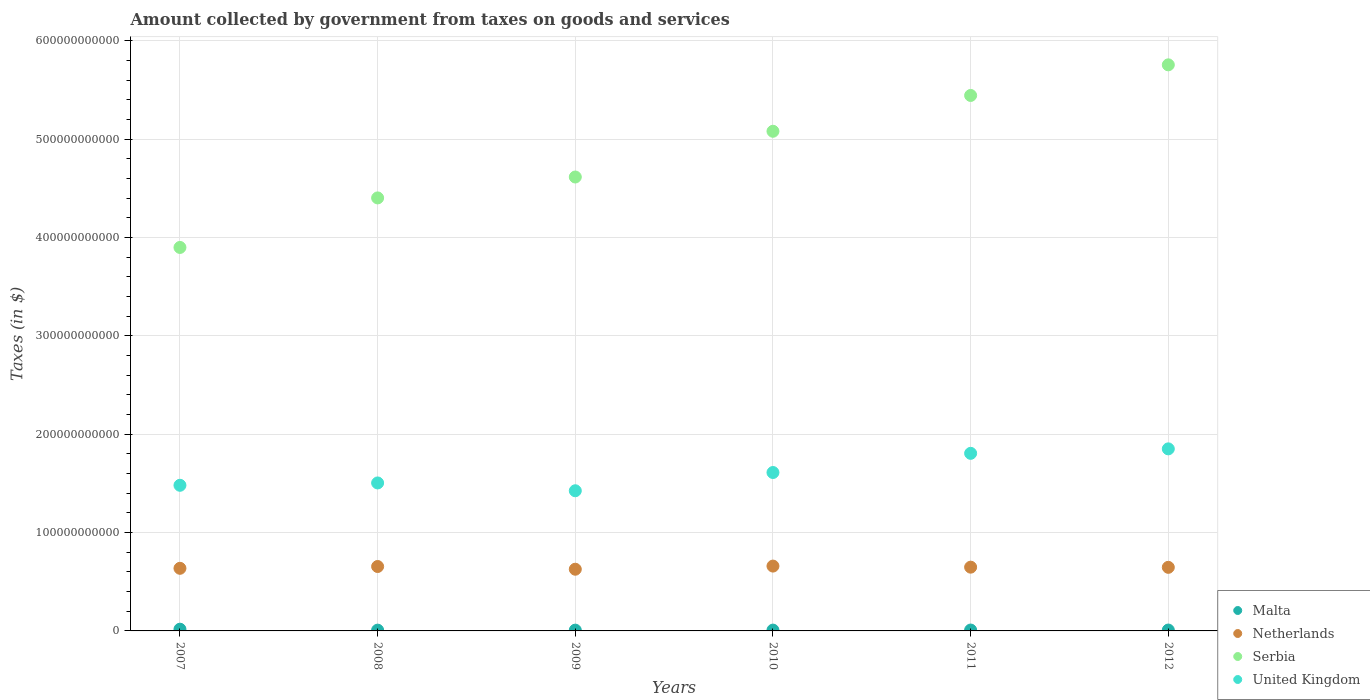How many different coloured dotlines are there?
Ensure brevity in your answer.  4. Is the number of dotlines equal to the number of legend labels?
Provide a succinct answer. Yes. What is the amount collected by government from taxes on goods and services in Serbia in 2008?
Ensure brevity in your answer.  4.40e+11. Across all years, what is the maximum amount collected by government from taxes on goods and services in Netherlands?
Your response must be concise. 6.59e+1. Across all years, what is the minimum amount collected by government from taxes on goods and services in United Kingdom?
Give a very brief answer. 1.43e+11. What is the total amount collected by government from taxes on goods and services in Malta in the graph?
Keep it short and to the point. 5.97e+09. What is the difference between the amount collected by government from taxes on goods and services in Malta in 2008 and that in 2011?
Give a very brief answer. -9.64e+07. What is the difference between the amount collected by government from taxes on goods and services in Netherlands in 2009 and the amount collected by government from taxes on goods and services in Malta in 2008?
Your response must be concise. 6.19e+1. What is the average amount collected by government from taxes on goods and services in Malta per year?
Ensure brevity in your answer.  9.95e+08. In the year 2011, what is the difference between the amount collected by government from taxes on goods and services in Serbia and amount collected by government from taxes on goods and services in Netherlands?
Provide a succinct answer. 4.80e+11. What is the ratio of the amount collected by government from taxes on goods and services in Malta in 2009 to that in 2010?
Provide a short and direct response. 0.97. What is the difference between the highest and the second highest amount collected by government from taxes on goods and services in Serbia?
Give a very brief answer. 3.11e+1. What is the difference between the highest and the lowest amount collected by government from taxes on goods and services in United Kingdom?
Provide a short and direct response. 4.26e+1. In how many years, is the amount collected by government from taxes on goods and services in United Kingdom greater than the average amount collected by government from taxes on goods and services in United Kingdom taken over all years?
Make the answer very short. 2. Is it the case that in every year, the sum of the amount collected by government from taxes on goods and services in United Kingdom and amount collected by government from taxes on goods and services in Serbia  is greater than the sum of amount collected by government from taxes on goods and services in Netherlands and amount collected by government from taxes on goods and services in Malta?
Your response must be concise. Yes. Does the amount collected by government from taxes on goods and services in Malta monotonically increase over the years?
Ensure brevity in your answer.  No. How many years are there in the graph?
Provide a short and direct response. 6. What is the difference between two consecutive major ticks on the Y-axis?
Provide a succinct answer. 1.00e+11. Are the values on the major ticks of Y-axis written in scientific E-notation?
Your answer should be compact. No. What is the title of the graph?
Your answer should be compact. Amount collected by government from taxes on goods and services. What is the label or title of the Y-axis?
Make the answer very short. Taxes (in $). What is the Taxes (in $) in Malta in 2007?
Your answer should be compact. 1.76e+09. What is the Taxes (in $) of Netherlands in 2007?
Ensure brevity in your answer.  6.37e+1. What is the Taxes (in $) of Serbia in 2007?
Give a very brief answer. 3.90e+11. What is the Taxes (in $) in United Kingdom in 2007?
Provide a succinct answer. 1.48e+11. What is the Taxes (in $) of Malta in 2008?
Your answer should be compact. 7.96e+08. What is the Taxes (in $) in Netherlands in 2008?
Provide a short and direct response. 6.55e+1. What is the Taxes (in $) in Serbia in 2008?
Provide a succinct answer. 4.40e+11. What is the Taxes (in $) of United Kingdom in 2008?
Your answer should be very brief. 1.50e+11. What is the Taxes (in $) of Malta in 2009?
Keep it short and to the point. 8.01e+08. What is the Taxes (in $) of Netherlands in 2009?
Keep it short and to the point. 6.27e+1. What is the Taxes (in $) of Serbia in 2009?
Offer a terse response. 4.62e+11. What is the Taxes (in $) in United Kingdom in 2009?
Ensure brevity in your answer.  1.43e+11. What is the Taxes (in $) in Malta in 2010?
Keep it short and to the point. 8.29e+08. What is the Taxes (in $) of Netherlands in 2010?
Provide a succinct answer. 6.59e+1. What is the Taxes (in $) in Serbia in 2010?
Offer a terse response. 5.08e+11. What is the Taxes (in $) in United Kingdom in 2010?
Give a very brief answer. 1.61e+11. What is the Taxes (in $) of Malta in 2011?
Keep it short and to the point. 8.92e+08. What is the Taxes (in $) in Netherlands in 2011?
Offer a terse response. 6.48e+1. What is the Taxes (in $) of Serbia in 2011?
Your answer should be compact. 5.45e+11. What is the Taxes (in $) of United Kingdom in 2011?
Your answer should be compact. 1.81e+11. What is the Taxes (in $) of Malta in 2012?
Keep it short and to the point. 8.92e+08. What is the Taxes (in $) in Netherlands in 2012?
Offer a terse response. 6.47e+1. What is the Taxes (in $) of Serbia in 2012?
Provide a succinct answer. 5.76e+11. What is the Taxes (in $) of United Kingdom in 2012?
Offer a terse response. 1.85e+11. Across all years, what is the maximum Taxes (in $) in Malta?
Your answer should be compact. 1.76e+09. Across all years, what is the maximum Taxes (in $) of Netherlands?
Your response must be concise. 6.59e+1. Across all years, what is the maximum Taxes (in $) in Serbia?
Keep it short and to the point. 5.76e+11. Across all years, what is the maximum Taxes (in $) of United Kingdom?
Provide a short and direct response. 1.85e+11. Across all years, what is the minimum Taxes (in $) in Malta?
Keep it short and to the point. 7.96e+08. Across all years, what is the minimum Taxes (in $) in Netherlands?
Give a very brief answer. 6.27e+1. Across all years, what is the minimum Taxes (in $) of Serbia?
Ensure brevity in your answer.  3.90e+11. Across all years, what is the minimum Taxes (in $) in United Kingdom?
Your response must be concise. 1.43e+11. What is the total Taxes (in $) of Malta in the graph?
Provide a succinct answer. 5.97e+09. What is the total Taxes (in $) in Netherlands in the graph?
Your answer should be compact. 3.87e+11. What is the total Taxes (in $) of Serbia in the graph?
Provide a succinct answer. 2.92e+12. What is the total Taxes (in $) in United Kingdom in the graph?
Give a very brief answer. 9.68e+11. What is the difference between the Taxes (in $) in Malta in 2007 and that in 2008?
Keep it short and to the point. 9.60e+08. What is the difference between the Taxes (in $) of Netherlands in 2007 and that in 2008?
Offer a very short reply. -1.84e+09. What is the difference between the Taxes (in $) of Serbia in 2007 and that in 2008?
Your answer should be compact. -5.04e+1. What is the difference between the Taxes (in $) in United Kingdom in 2007 and that in 2008?
Provide a short and direct response. -2.39e+09. What is the difference between the Taxes (in $) of Malta in 2007 and that in 2009?
Your answer should be compact. 9.56e+08. What is the difference between the Taxes (in $) in Netherlands in 2007 and that in 2009?
Provide a short and direct response. 9.29e+08. What is the difference between the Taxes (in $) in Serbia in 2007 and that in 2009?
Give a very brief answer. -7.16e+1. What is the difference between the Taxes (in $) of United Kingdom in 2007 and that in 2009?
Offer a very short reply. 5.55e+09. What is the difference between the Taxes (in $) of Malta in 2007 and that in 2010?
Give a very brief answer. 9.27e+08. What is the difference between the Taxes (in $) of Netherlands in 2007 and that in 2010?
Offer a terse response. -2.27e+09. What is the difference between the Taxes (in $) in Serbia in 2007 and that in 2010?
Your answer should be compact. -1.18e+11. What is the difference between the Taxes (in $) of United Kingdom in 2007 and that in 2010?
Your answer should be very brief. -1.30e+1. What is the difference between the Taxes (in $) in Malta in 2007 and that in 2011?
Your answer should be very brief. 8.64e+08. What is the difference between the Taxes (in $) of Netherlands in 2007 and that in 2011?
Your answer should be very brief. -1.16e+09. What is the difference between the Taxes (in $) of Serbia in 2007 and that in 2011?
Your answer should be very brief. -1.55e+11. What is the difference between the Taxes (in $) in United Kingdom in 2007 and that in 2011?
Your answer should be compact. -3.25e+1. What is the difference between the Taxes (in $) in Malta in 2007 and that in 2012?
Provide a succinct answer. 8.64e+08. What is the difference between the Taxes (in $) of Netherlands in 2007 and that in 2012?
Provide a short and direct response. -9.96e+08. What is the difference between the Taxes (in $) of Serbia in 2007 and that in 2012?
Your answer should be compact. -1.86e+11. What is the difference between the Taxes (in $) in United Kingdom in 2007 and that in 2012?
Give a very brief answer. -3.70e+1. What is the difference between the Taxes (in $) of Malta in 2008 and that in 2009?
Make the answer very short. -4.79e+06. What is the difference between the Taxes (in $) of Netherlands in 2008 and that in 2009?
Give a very brief answer. 2.77e+09. What is the difference between the Taxes (in $) of Serbia in 2008 and that in 2009?
Your answer should be compact. -2.13e+1. What is the difference between the Taxes (in $) in United Kingdom in 2008 and that in 2009?
Provide a short and direct response. 7.94e+09. What is the difference between the Taxes (in $) in Malta in 2008 and that in 2010?
Your answer should be compact. -3.33e+07. What is the difference between the Taxes (in $) in Netherlands in 2008 and that in 2010?
Provide a succinct answer. -4.29e+08. What is the difference between the Taxes (in $) in Serbia in 2008 and that in 2010?
Your answer should be very brief. -6.78e+1. What is the difference between the Taxes (in $) in United Kingdom in 2008 and that in 2010?
Your response must be concise. -1.06e+1. What is the difference between the Taxes (in $) of Malta in 2008 and that in 2011?
Ensure brevity in your answer.  -9.64e+07. What is the difference between the Taxes (in $) in Netherlands in 2008 and that in 2011?
Your answer should be very brief. 6.73e+08. What is the difference between the Taxes (in $) in Serbia in 2008 and that in 2011?
Provide a short and direct response. -1.04e+11. What is the difference between the Taxes (in $) in United Kingdom in 2008 and that in 2011?
Provide a succinct answer. -3.01e+1. What is the difference between the Taxes (in $) of Malta in 2008 and that in 2012?
Offer a very short reply. -9.65e+07. What is the difference between the Taxes (in $) of Netherlands in 2008 and that in 2012?
Offer a terse response. 8.42e+08. What is the difference between the Taxes (in $) of Serbia in 2008 and that in 2012?
Make the answer very short. -1.35e+11. What is the difference between the Taxes (in $) in United Kingdom in 2008 and that in 2012?
Keep it short and to the point. -3.47e+1. What is the difference between the Taxes (in $) of Malta in 2009 and that in 2010?
Your answer should be very brief. -2.85e+07. What is the difference between the Taxes (in $) in Netherlands in 2009 and that in 2010?
Your answer should be compact. -3.20e+09. What is the difference between the Taxes (in $) in Serbia in 2009 and that in 2010?
Offer a terse response. -4.65e+1. What is the difference between the Taxes (in $) in United Kingdom in 2009 and that in 2010?
Provide a short and direct response. -1.86e+1. What is the difference between the Taxes (in $) of Malta in 2009 and that in 2011?
Your answer should be compact. -9.16e+07. What is the difference between the Taxes (in $) of Netherlands in 2009 and that in 2011?
Your response must be concise. -2.09e+09. What is the difference between the Taxes (in $) in Serbia in 2009 and that in 2011?
Give a very brief answer. -8.29e+1. What is the difference between the Taxes (in $) of United Kingdom in 2009 and that in 2011?
Offer a very short reply. -3.80e+1. What is the difference between the Taxes (in $) of Malta in 2009 and that in 2012?
Your answer should be very brief. -9.17e+07. What is the difference between the Taxes (in $) of Netherlands in 2009 and that in 2012?
Your response must be concise. -1.92e+09. What is the difference between the Taxes (in $) of Serbia in 2009 and that in 2012?
Ensure brevity in your answer.  -1.14e+11. What is the difference between the Taxes (in $) of United Kingdom in 2009 and that in 2012?
Offer a terse response. -4.26e+1. What is the difference between the Taxes (in $) of Malta in 2010 and that in 2011?
Give a very brief answer. -6.32e+07. What is the difference between the Taxes (in $) of Netherlands in 2010 and that in 2011?
Give a very brief answer. 1.10e+09. What is the difference between the Taxes (in $) of Serbia in 2010 and that in 2011?
Your response must be concise. -3.64e+1. What is the difference between the Taxes (in $) in United Kingdom in 2010 and that in 2011?
Your answer should be compact. -1.95e+1. What is the difference between the Taxes (in $) of Malta in 2010 and that in 2012?
Give a very brief answer. -6.33e+07. What is the difference between the Taxes (in $) of Netherlands in 2010 and that in 2012?
Provide a short and direct response. 1.27e+09. What is the difference between the Taxes (in $) in Serbia in 2010 and that in 2012?
Your answer should be compact. -6.76e+1. What is the difference between the Taxes (in $) in United Kingdom in 2010 and that in 2012?
Offer a very short reply. -2.40e+1. What is the difference between the Taxes (in $) in Malta in 2011 and that in 2012?
Offer a terse response. -1.06e+05. What is the difference between the Taxes (in $) of Netherlands in 2011 and that in 2012?
Make the answer very short. 1.69e+08. What is the difference between the Taxes (in $) of Serbia in 2011 and that in 2012?
Offer a very short reply. -3.11e+1. What is the difference between the Taxes (in $) in United Kingdom in 2011 and that in 2012?
Offer a very short reply. -4.55e+09. What is the difference between the Taxes (in $) in Malta in 2007 and the Taxes (in $) in Netherlands in 2008?
Provide a succinct answer. -6.37e+1. What is the difference between the Taxes (in $) in Malta in 2007 and the Taxes (in $) in Serbia in 2008?
Offer a terse response. -4.39e+11. What is the difference between the Taxes (in $) in Malta in 2007 and the Taxes (in $) in United Kingdom in 2008?
Offer a very short reply. -1.49e+11. What is the difference between the Taxes (in $) in Netherlands in 2007 and the Taxes (in $) in Serbia in 2008?
Offer a terse response. -3.77e+11. What is the difference between the Taxes (in $) of Netherlands in 2007 and the Taxes (in $) of United Kingdom in 2008?
Keep it short and to the point. -8.68e+1. What is the difference between the Taxes (in $) of Serbia in 2007 and the Taxes (in $) of United Kingdom in 2008?
Offer a terse response. 2.39e+11. What is the difference between the Taxes (in $) in Malta in 2007 and the Taxes (in $) in Netherlands in 2009?
Ensure brevity in your answer.  -6.10e+1. What is the difference between the Taxes (in $) in Malta in 2007 and the Taxes (in $) in Serbia in 2009?
Offer a terse response. -4.60e+11. What is the difference between the Taxes (in $) of Malta in 2007 and the Taxes (in $) of United Kingdom in 2009?
Keep it short and to the point. -1.41e+11. What is the difference between the Taxes (in $) in Netherlands in 2007 and the Taxes (in $) in Serbia in 2009?
Give a very brief answer. -3.98e+11. What is the difference between the Taxes (in $) in Netherlands in 2007 and the Taxes (in $) in United Kingdom in 2009?
Your answer should be compact. -7.89e+1. What is the difference between the Taxes (in $) of Serbia in 2007 and the Taxes (in $) of United Kingdom in 2009?
Offer a very short reply. 2.47e+11. What is the difference between the Taxes (in $) of Malta in 2007 and the Taxes (in $) of Netherlands in 2010?
Your answer should be very brief. -6.42e+1. What is the difference between the Taxes (in $) of Malta in 2007 and the Taxes (in $) of Serbia in 2010?
Offer a terse response. -5.06e+11. What is the difference between the Taxes (in $) in Malta in 2007 and the Taxes (in $) in United Kingdom in 2010?
Keep it short and to the point. -1.59e+11. What is the difference between the Taxes (in $) of Netherlands in 2007 and the Taxes (in $) of Serbia in 2010?
Your response must be concise. -4.44e+11. What is the difference between the Taxes (in $) in Netherlands in 2007 and the Taxes (in $) in United Kingdom in 2010?
Offer a very short reply. -9.74e+1. What is the difference between the Taxes (in $) of Serbia in 2007 and the Taxes (in $) of United Kingdom in 2010?
Your answer should be very brief. 2.29e+11. What is the difference between the Taxes (in $) in Malta in 2007 and the Taxes (in $) in Netherlands in 2011?
Your answer should be very brief. -6.31e+1. What is the difference between the Taxes (in $) in Malta in 2007 and the Taxes (in $) in Serbia in 2011?
Keep it short and to the point. -5.43e+11. What is the difference between the Taxes (in $) of Malta in 2007 and the Taxes (in $) of United Kingdom in 2011?
Provide a short and direct response. -1.79e+11. What is the difference between the Taxes (in $) in Netherlands in 2007 and the Taxes (in $) in Serbia in 2011?
Your answer should be compact. -4.81e+11. What is the difference between the Taxes (in $) in Netherlands in 2007 and the Taxes (in $) in United Kingdom in 2011?
Offer a terse response. -1.17e+11. What is the difference between the Taxes (in $) of Serbia in 2007 and the Taxes (in $) of United Kingdom in 2011?
Provide a short and direct response. 2.09e+11. What is the difference between the Taxes (in $) in Malta in 2007 and the Taxes (in $) in Netherlands in 2012?
Provide a succinct answer. -6.29e+1. What is the difference between the Taxes (in $) in Malta in 2007 and the Taxes (in $) in Serbia in 2012?
Your answer should be very brief. -5.74e+11. What is the difference between the Taxes (in $) in Malta in 2007 and the Taxes (in $) in United Kingdom in 2012?
Your answer should be compact. -1.83e+11. What is the difference between the Taxes (in $) of Netherlands in 2007 and the Taxes (in $) of Serbia in 2012?
Your response must be concise. -5.12e+11. What is the difference between the Taxes (in $) in Netherlands in 2007 and the Taxes (in $) in United Kingdom in 2012?
Provide a short and direct response. -1.21e+11. What is the difference between the Taxes (in $) in Serbia in 2007 and the Taxes (in $) in United Kingdom in 2012?
Ensure brevity in your answer.  2.05e+11. What is the difference between the Taxes (in $) of Malta in 2008 and the Taxes (in $) of Netherlands in 2009?
Offer a very short reply. -6.19e+1. What is the difference between the Taxes (in $) of Malta in 2008 and the Taxes (in $) of Serbia in 2009?
Your answer should be very brief. -4.61e+11. What is the difference between the Taxes (in $) in Malta in 2008 and the Taxes (in $) in United Kingdom in 2009?
Provide a succinct answer. -1.42e+11. What is the difference between the Taxes (in $) of Netherlands in 2008 and the Taxes (in $) of Serbia in 2009?
Ensure brevity in your answer.  -3.96e+11. What is the difference between the Taxes (in $) of Netherlands in 2008 and the Taxes (in $) of United Kingdom in 2009?
Make the answer very short. -7.70e+1. What is the difference between the Taxes (in $) of Serbia in 2008 and the Taxes (in $) of United Kingdom in 2009?
Your answer should be compact. 2.98e+11. What is the difference between the Taxes (in $) of Malta in 2008 and the Taxes (in $) of Netherlands in 2010?
Keep it short and to the point. -6.51e+1. What is the difference between the Taxes (in $) in Malta in 2008 and the Taxes (in $) in Serbia in 2010?
Provide a short and direct response. -5.07e+11. What is the difference between the Taxes (in $) of Malta in 2008 and the Taxes (in $) of United Kingdom in 2010?
Offer a very short reply. -1.60e+11. What is the difference between the Taxes (in $) of Netherlands in 2008 and the Taxes (in $) of Serbia in 2010?
Provide a succinct answer. -4.43e+11. What is the difference between the Taxes (in $) of Netherlands in 2008 and the Taxes (in $) of United Kingdom in 2010?
Give a very brief answer. -9.56e+1. What is the difference between the Taxes (in $) in Serbia in 2008 and the Taxes (in $) in United Kingdom in 2010?
Your response must be concise. 2.79e+11. What is the difference between the Taxes (in $) in Malta in 2008 and the Taxes (in $) in Netherlands in 2011?
Your answer should be compact. -6.40e+1. What is the difference between the Taxes (in $) in Malta in 2008 and the Taxes (in $) in Serbia in 2011?
Offer a very short reply. -5.44e+11. What is the difference between the Taxes (in $) of Malta in 2008 and the Taxes (in $) of United Kingdom in 2011?
Give a very brief answer. -1.80e+11. What is the difference between the Taxes (in $) of Netherlands in 2008 and the Taxes (in $) of Serbia in 2011?
Your answer should be very brief. -4.79e+11. What is the difference between the Taxes (in $) of Netherlands in 2008 and the Taxes (in $) of United Kingdom in 2011?
Ensure brevity in your answer.  -1.15e+11. What is the difference between the Taxes (in $) in Serbia in 2008 and the Taxes (in $) in United Kingdom in 2011?
Your answer should be very brief. 2.60e+11. What is the difference between the Taxes (in $) in Malta in 2008 and the Taxes (in $) in Netherlands in 2012?
Keep it short and to the point. -6.39e+1. What is the difference between the Taxes (in $) of Malta in 2008 and the Taxes (in $) of Serbia in 2012?
Offer a very short reply. -5.75e+11. What is the difference between the Taxes (in $) in Malta in 2008 and the Taxes (in $) in United Kingdom in 2012?
Give a very brief answer. -1.84e+11. What is the difference between the Taxes (in $) in Netherlands in 2008 and the Taxes (in $) in Serbia in 2012?
Your answer should be compact. -5.10e+11. What is the difference between the Taxes (in $) of Netherlands in 2008 and the Taxes (in $) of United Kingdom in 2012?
Provide a succinct answer. -1.20e+11. What is the difference between the Taxes (in $) of Serbia in 2008 and the Taxes (in $) of United Kingdom in 2012?
Keep it short and to the point. 2.55e+11. What is the difference between the Taxes (in $) in Malta in 2009 and the Taxes (in $) in Netherlands in 2010?
Offer a terse response. -6.51e+1. What is the difference between the Taxes (in $) of Malta in 2009 and the Taxes (in $) of Serbia in 2010?
Keep it short and to the point. -5.07e+11. What is the difference between the Taxes (in $) in Malta in 2009 and the Taxes (in $) in United Kingdom in 2010?
Ensure brevity in your answer.  -1.60e+11. What is the difference between the Taxes (in $) of Netherlands in 2009 and the Taxes (in $) of Serbia in 2010?
Give a very brief answer. -4.45e+11. What is the difference between the Taxes (in $) in Netherlands in 2009 and the Taxes (in $) in United Kingdom in 2010?
Ensure brevity in your answer.  -9.83e+1. What is the difference between the Taxes (in $) in Serbia in 2009 and the Taxes (in $) in United Kingdom in 2010?
Give a very brief answer. 3.01e+11. What is the difference between the Taxes (in $) in Malta in 2009 and the Taxes (in $) in Netherlands in 2011?
Your response must be concise. -6.40e+1. What is the difference between the Taxes (in $) in Malta in 2009 and the Taxes (in $) in Serbia in 2011?
Provide a short and direct response. -5.44e+11. What is the difference between the Taxes (in $) in Malta in 2009 and the Taxes (in $) in United Kingdom in 2011?
Provide a succinct answer. -1.80e+11. What is the difference between the Taxes (in $) of Netherlands in 2009 and the Taxes (in $) of Serbia in 2011?
Keep it short and to the point. -4.82e+11. What is the difference between the Taxes (in $) of Netherlands in 2009 and the Taxes (in $) of United Kingdom in 2011?
Give a very brief answer. -1.18e+11. What is the difference between the Taxes (in $) in Serbia in 2009 and the Taxes (in $) in United Kingdom in 2011?
Your answer should be compact. 2.81e+11. What is the difference between the Taxes (in $) in Malta in 2009 and the Taxes (in $) in Netherlands in 2012?
Ensure brevity in your answer.  -6.39e+1. What is the difference between the Taxes (in $) in Malta in 2009 and the Taxes (in $) in Serbia in 2012?
Offer a very short reply. -5.75e+11. What is the difference between the Taxes (in $) in Malta in 2009 and the Taxes (in $) in United Kingdom in 2012?
Your answer should be very brief. -1.84e+11. What is the difference between the Taxes (in $) of Netherlands in 2009 and the Taxes (in $) of Serbia in 2012?
Provide a short and direct response. -5.13e+11. What is the difference between the Taxes (in $) in Netherlands in 2009 and the Taxes (in $) in United Kingdom in 2012?
Make the answer very short. -1.22e+11. What is the difference between the Taxes (in $) of Serbia in 2009 and the Taxes (in $) of United Kingdom in 2012?
Provide a succinct answer. 2.76e+11. What is the difference between the Taxes (in $) of Malta in 2010 and the Taxes (in $) of Netherlands in 2011?
Offer a very short reply. -6.40e+1. What is the difference between the Taxes (in $) of Malta in 2010 and the Taxes (in $) of Serbia in 2011?
Keep it short and to the point. -5.44e+11. What is the difference between the Taxes (in $) of Malta in 2010 and the Taxes (in $) of United Kingdom in 2011?
Ensure brevity in your answer.  -1.80e+11. What is the difference between the Taxes (in $) in Netherlands in 2010 and the Taxes (in $) in Serbia in 2011?
Offer a terse response. -4.79e+11. What is the difference between the Taxes (in $) of Netherlands in 2010 and the Taxes (in $) of United Kingdom in 2011?
Ensure brevity in your answer.  -1.15e+11. What is the difference between the Taxes (in $) of Serbia in 2010 and the Taxes (in $) of United Kingdom in 2011?
Offer a terse response. 3.28e+11. What is the difference between the Taxes (in $) in Malta in 2010 and the Taxes (in $) in Netherlands in 2012?
Give a very brief answer. -6.38e+1. What is the difference between the Taxes (in $) of Malta in 2010 and the Taxes (in $) of Serbia in 2012?
Give a very brief answer. -5.75e+11. What is the difference between the Taxes (in $) in Malta in 2010 and the Taxes (in $) in United Kingdom in 2012?
Your response must be concise. -1.84e+11. What is the difference between the Taxes (in $) in Netherlands in 2010 and the Taxes (in $) in Serbia in 2012?
Your answer should be compact. -5.10e+11. What is the difference between the Taxes (in $) of Netherlands in 2010 and the Taxes (in $) of United Kingdom in 2012?
Your answer should be compact. -1.19e+11. What is the difference between the Taxes (in $) of Serbia in 2010 and the Taxes (in $) of United Kingdom in 2012?
Offer a very short reply. 3.23e+11. What is the difference between the Taxes (in $) in Malta in 2011 and the Taxes (in $) in Netherlands in 2012?
Your answer should be very brief. -6.38e+1. What is the difference between the Taxes (in $) of Malta in 2011 and the Taxes (in $) of Serbia in 2012?
Offer a very short reply. -5.75e+11. What is the difference between the Taxes (in $) in Malta in 2011 and the Taxes (in $) in United Kingdom in 2012?
Keep it short and to the point. -1.84e+11. What is the difference between the Taxes (in $) in Netherlands in 2011 and the Taxes (in $) in Serbia in 2012?
Keep it short and to the point. -5.11e+11. What is the difference between the Taxes (in $) in Netherlands in 2011 and the Taxes (in $) in United Kingdom in 2012?
Your response must be concise. -1.20e+11. What is the difference between the Taxes (in $) of Serbia in 2011 and the Taxes (in $) of United Kingdom in 2012?
Offer a very short reply. 3.59e+11. What is the average Taxes (in $) in Malta per year?
Keep it short and to the point. 9.95e+08. What is the average Taxes (in $) of Netherlands per year?
Offer a very short reply. 6.46e+1. What is the average Taxes (in $) of Serbia per year?
Your answer should be very brief. 4.87e+11. What is the average Taxes (in $) in United Kingdom per year?
Ensure brevity in your answer.  1.61e+11. In the year 2007, what is the difference between the Taxes (in $) in Malta and Taxes (in $) in Netherlands?
Offer a very short reply. -6.19e+1. In the year 2007, what is the difference between the Taxes (in $) in Malta and Taxes (in $) in Serbia?
Keep it short and to the point. -3.88e+11. In the year 2007, what is the difference between the Taxes (in $) of Malta and Taxes (in $) of United Kingdom?
Your answer should be very brief. -1.46e+11. In the year 2007, what is the difference between the Taxes (in $) of Netherlands and Taxes (in $) of Serbia?
Provide a succinct answer. -3.26e+11. In the year 2007, what is the difference between the Taxes (in $) in Netherlands and Taxes (in $) in United Kingdom?
Offer a terse response. -8.44e+1. In the year 2007, what is the difference between the Taxes (in $) of Serbia and Taxes (in $) of United Kingdom?
Offer a terse response. 2.42e+11. In the year 2008, what is the difference between the Taxes (in $) of Malta and Taxes (in $) of Netherlands?
Provide a short and direct response. -6.47e+1. In the year 2008, what is the difference between the Taxes (in $) of Malta and Taxes (in $) of Serbia?
Your answer should be very brief. -4.40e+11. In the year 2008, what is the difference between the Taxes (in $) of Malta and Taxes (in $) of United Kingdom?
Keep it short and to the point. -1.50e+11. In the year 2008, what is the difference between the Taxes (in $) of Netherlands and Taxes (in $) of Serbia?
Offer a very short reply. -3.75e+11. In the year 2008, what is the difference between the Taxes (in $) of Netherlands and Taxes (in $) of United Kingdom?
Keep it short and to the point. -8.50e+1. In the year 2008, what is the difference between the Taxes (in $) in Serbia and Taxes (in $) in United Kingdom?
Make the answer very short. 2.90e+11. In the year 2009, what is the difference between the Taxes (in $) of Malta and Taxes (in $) of Netherlands?
Provide a short and direct response. -6.19e+1. In the year 2009, what is the difference between the Taxes (in $) in Malta and Taxes (in $) in Serbia?
Your answer should be compact. -4.61e+11. In the year 2009, what is the difference between the Taxes (in $) in Malta and Taxes (in $) in United Kingdom?
Your answer should be very brief. -1.42e+11. In the year 2009, what is the difference between the Taxes (in $) of Netherlands and Taxes (in $) of Serbia?
Give a very brief answer. -3.99e+11. In the year 2009, what is the difference between the Taxes (in $) of Netherlands and Taxes (in $) of United Kingdom?
Your answer should be compact. -7.98e+1. In the year 2009, what is the difference between the Taxes (in $) of Serbia and Taxes (in $) of United Kingdom?
Give a very brief answer. 3.19e+11. In the year 2010, what is the difference between the Taxes (in $) in Malta and Taxes (in $) in Netherlands?
Your answer should be compact. -6.51e+1. In the year 2010, what is the difference between the Taxes (in $) in Malta and Taxes (in $) in Serbia?
Provide a short and direct response. -5.07e+11. In the year 2010, what is the difference between the Taxes (in $) in Malta and Taxes (in $) in United Kingdom?
Offer a very short reply. -1.60e+11. In the year 2010, what is the difference between the Taxes (in $) of Netherlands and Taxes (in $) of Serbia?
Keep it short and to the point. -4.42e+11. In the year 2010, what is the difference between the Taxes (in $) in Netherlands and Taxes (in $) in United Kingdom?
Keep it short and to the point. -9.52e+1. In the year 2010, what is the difference between the Taxes (in $) in Serbia and Taxes (in $) in United Kingdom?
Offer a terse response. 3.47e+11. In the year 2011, what is the difference between the Taxes (in $) of Malta and Taxes (in $) of Netherlands?
Your response must be concise. -6.39e+1. In the year 2011, what is the difference between the Taxes (in $) of Malta and Taxes (in $) of Serbia?
Your response must be concise. -5.44e+11. In the year 2011, what is the difference between the Taxes (in $) in Malta and Taxes (in $) in United Kingdom?
Your response must be concise. -1.80e+11. In the year 2011, what is the difference between the Taxes (in $) in Netherlands and Taxes (in $) in Serbia?
Your answer should be very brief. -4.80e+11. In the year 2011, what is the difference between the Taxes (in $) of Netherlands and Taxes (in $) of United Kingdom?
Your answer should be very brief. -1.16e+11. In the year 2011, what is the difference between the Taxes (in $) of Serbia and Taxes (in $) of United Kingdom?
Offer a terse response. 3.64e+11. In the year 2012, what is the difference between the Taxes (in $) in Malta and Taxes (in $) in Netherlands?
Provide a short and direct response. -6.38e+1. In the year 2012, what is the difference between the Taxes (in $) of Malta and Taxes (in $) of Serbia?
Your response must be concise. -5.75e+11. In the year 2012, what is the difference between the Taxes (in $) of Malta and Taxes (in $) of United Kingdom?
Your response must be concise. -1.84e+11. In the year 2012, what is the difference between the Taxes (in $) in Netherlands and Taxes (in $) in Serbia?
Make the answer very short. -5.11e+11. In the year 2012, what is the difference between the Taxes (in $) of Netherlands and Taxes (in $) of United Kingdom?
Keep it short and to the point. -1.20e+11. In the year 2012, what is the difference between the Taxes (in $) in Serbia and Taxes (in $) in United Kingdom?
Offer a very short reply. 3.91e+11. What is the ratio of the Taxes (in $) of Malta in 2007 to that in 2008?
Ensure brevity in your answer.  2.21. What is the ratio of the Taxes (in $) in Netherlands in 2007 to that in 2008?
Ensure brevity in your answer.  0.97. What is the ratio of the Taxes (in $) in Serbia in 2007 to that in 2008?
Ensure brevity in your answer.  0.89. What is the ratio of the Taxes (in $) of United Kingdom in 2007 to that in 2008?
Give a very brief answer. 0.98. What is the ratio of the Taxes (in $) in Malta in 2007 to that in 2009?
Your answer should be compact. 2.19. What is the ratio of the Taxes (in $) of Netherlands in 2007 to that in 2009?
Provide a succinct answer. 1.01. What is the ratio of the Taxes (in $) of Serbia in 2007 to that in 2009?
Ensure brevity in your answer.  0.84. What is the ratio of the Taxes (in $) in United Kingdom in 2007 to that in 2009?
Give a very brief answer. 1.04. What is the ratio of the Taxes (in $) in Malta in 2007 to that in 2010?
Provide a short and direct response. 2.12. What is the ratio of the Taxes (in $) of Netherlands in 2007 to that in 2010?
Offer a terse response. 0.97. What is the ratio of the Taxes (in $) of Serbia in 2007 to that in 2010?
Your answer should be compact. 0.77. What is the ratio of the Taxes (in $) of United Kingdom in 2007 to that in 2010?
Provide a succinct answer. 0.92. What is the ratio of the Taxes (in $) in Malta in 2007 to that in 2011?
Provide a succinct answer. 1.97. What is the ratio of the Taxes (in $) in Netherlands in 2007 to that in 2011?
Ensure brevity in your answer.  0.98. What is the ratio of the Taxes (in $) of Serbia in 2007 to that in 2011?
Offer a terse response. 0.72. What is the ratio of the Taxes (in $) in United Kingdom in 2007 to that in 2011?
Offer a very short reply. 0.82. What is the ratio of the Taxes (in $) in Malta in 2007 to that in 2012?
Provide a succinct answer. 1.97. What is the ratio of the Taxes (in $) in Netherlands in 2007 to that in 2012?
Give a very brief answer. 0.98. What is the ratio of the Taxes (in $) of Serbia in 2007 to that in 2012?
Give a very brief answer. 0.68. What is the ratio of the Taxes (in $) in United Kingdom in 2007 to that in 2012?
Your answer should be very brief. 0.8. What is the ratio of the Taxes (in $) in Malta in 2008 to that in 2009?
Offer a very short reply. 0.99. What is the ratio of the Taxes (in $) of Netherlands in 2008 to that in 2009?
Your answer should be compact. 1.04. What is the ratio of the Taxes (in $) of Serbia in 2008 to that in 2009?
Provide a succinct answer. 0.95. What is the ratio of the Taxes (in $) in United Kingdom in 2008 to that in 2009?
Give a very brief answer. 1.06. What is the ratio of the Taxes (in $) of Malta in 2008 to that in 2010?
Give a very brief answer. 0.96. What is the ratio of the Taxes (in $) in Netherlands in 2008 to that in 2010?
Your answer should be compact. 0.99. What is the ratio of the Taxes (in $) in Serbia in 2008 to that in 2010?
Give a very brief answer. 0.87. What is the ratio of the Taxes (in $) of United Kingdom in 2008 to that in 2010?
Make the answer very short. 0.93. What is the ratio of the Taxes (in $) of Malta in 2008 to that in 2011?
Provide a short and direct response. 0.89. What is the ratio of the Taxes (in $) of Netherlands in 2008 to that in 2011?
Provide a succinct answer. 1.01. What is the ratio of the Taxes (in $) of Serbia in 2008 to that in 2011?
Your response must be concise. 0.81. What is the ratio of the Taxes (in $) of Malta in 2008 to that in 2012?
Offer a terse response. 0.89. What is the ratio of the Taxes (in $) in Serbia in 2008 to that in 2012?
Keep it short and to the point. 0.76. What is the ratio of the Taxes (in $) in United Kingdom in 2008 to that in 2012?
Make the answer very short. 0.81. What is the ratio of the Taxes (in $) of Malta in 2009 to that in 2010?
Ensure brevity in your answer.  0.97. What is the ratio of the Taxes (in $) of Netherlands in 2009 to that in 2010?
Make the answer very short. 0.95. What is the ratio of the Taxes (in $) of Serbia in 2009 to that in 2010?
Offer a terse response. 0.91. What is the ratio of the Taxes (in $) in United Kingdom in 2009 to that in 2010?
Keep it short and to the point. 0.88. What is the ratio of the Taxes (in $) of Malta in 2009 to that in 2011?
Offer a very short reply. 0.9. What is the ratio of the Taxes (in $) of Netherlands in 2009 to that in 2011?
Offer a terse response. 0.97. What is the ratio of the Taxes (in $) in Serbia in 2009 to that in 2011?
Your response must be concise. 0.85. What is the ratio of the Taxes (in $) in United Kingdom in 2009 to that in 2011?
Your response must be concise. 0.79. What is the ratio of the Taxes (in $) of Malta in 2009 to that in 2012?
Provide a short and direct response. 0.9. What is the ratio of the Taxes (in $) of Netherlands in 2009 to that in 2012?
Offer a very short reply. 0.97. What is the ratio of the Taxes (in $) of Serbia in 2009 to that in 2012?
Offer a very short reply. 0.8. What is the ratio of the Taxes (in $) of United Kingdom in 2009 to that in 2012?
Provide a succinct answer. 0.77. What is the ratio of the Taxes (in $) of Malta in 2010 to that in 2011?
Your response must be concise. 0.93. What is the ratio of the Taxes (in $) of Serbia in 2010 to that in 2011?
Your response must be concise. 0.93. What is the ratio of the Taxes (in $) in United Kingdom in 2010 to that in 2011?
Offer a very short reply. 0.89. What is the ratio of the Taxes (in $) in Malta in 2010 to that in 2012?
Provide a succinct answer. 0.93. What is the ratio of the Taxes (in $) in Netherlands in 2010 to that in 2012?
Your response must be concise. 1.02. What is the ratio of the Taxes (in $) of Serbia in 2010 to that in 2012?
Give a very brief answer. 0.88. What is the ratio of the Taxes (in $) in United Kingdom in 2010 to that in 2012?
Your response must be concise. 0.87. What is the ratio of the Taxes (in $) in Malta in 2011 to that in 2012?
Offer a very short reply. 1. What is the ratio of the Taxes (in $) of Netherlands in 2011 to that in 2012?
Ensure brevity in your answer.  1. What is the ratio of the Taxes (in $) in Serbia in 2011 to that in 2012?
Ensure brevity in your answer.  0.95. What is the ratio of the Taxes (in $) of United Kingdom in 2011 to that in 2012?
Offer a terse response. 0.98. What is the difference between the highest and the second highest Taxes (in $) in Malta?
Your answer should be very brief. 8.64e+08. What is the difference between the highest and the second highest Taxes (in $) in Netherlands?
Your answer should be very brief. 4.29e+08. What is the difference between the highest and the second highest Taxes (in $) of Serbia?
Keep it short and to the point. 3.11e+1. What is the difference between the highest and the second highest Taxes (in $) in United Kingdom?
Keep it short and to the point. 4.55e+09. What is the difference between the highest and the lowest Taxes (in $) in Malta?
Make the answer very short. 9.60e+08. What is the difference between the highest and the lowest Taxes (in $) in Netherlands?
Your response must be concise. 3.20e+09. What is the difference between the highest and the lowest Taxes (in $) of Serbia?
Provide a short and direct response. 1.86e+11. What is the difference between the highest and the lowest Taxes (in $) in United Kingdom?
Give a very brief answer. 4.26e+1. 